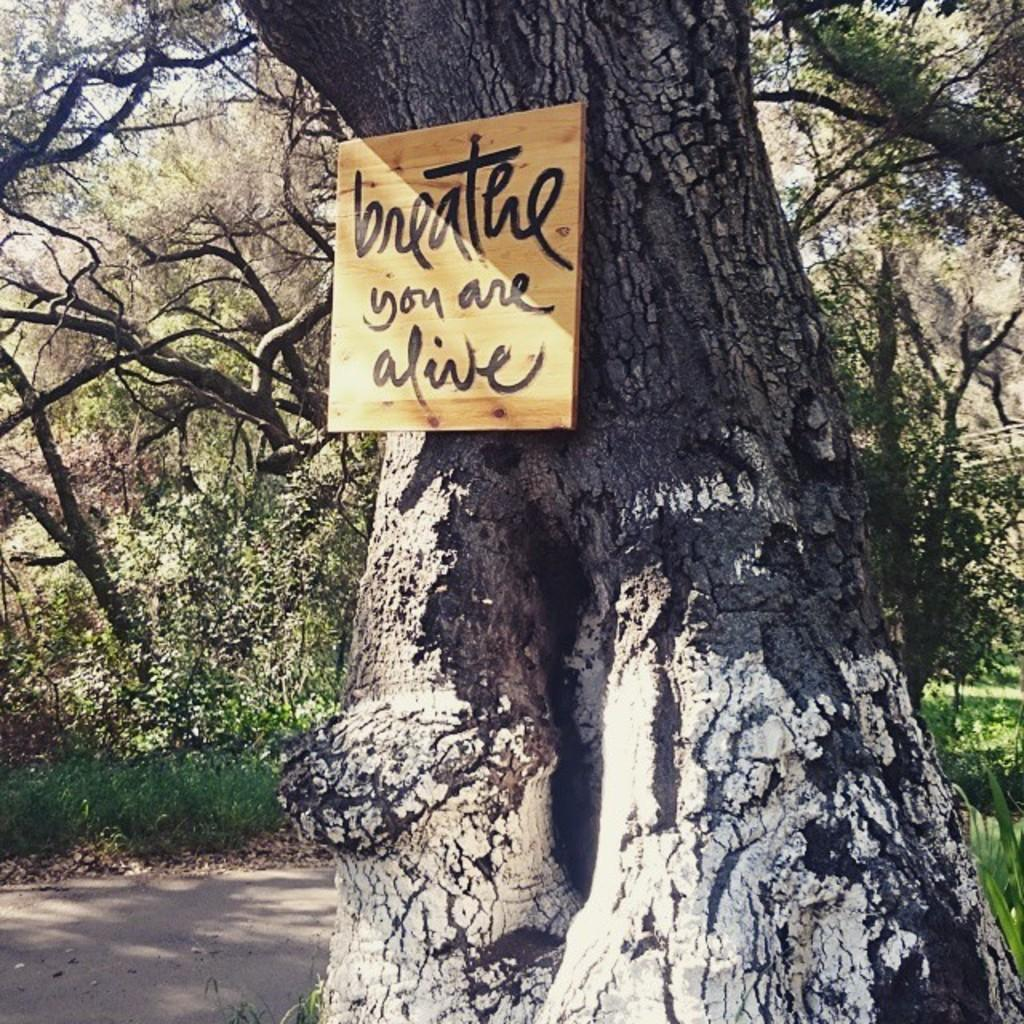What is the main object in the image? There is a tree trunk in the image. What is attached to the tree trunk? There is a small board on the tree trunk. What type of vegetation can be seen in the image? There are plants and trees visible in the image. What type of man-made structure can be seen in the image? There is a road in the image. What type of letter is being written on the quilt in the image? There is no letter or quilt present in the image. What kind of apparatus is being used to trim the trees in the image? There is no apparatus or tree-trimming activity depicted in the image. 